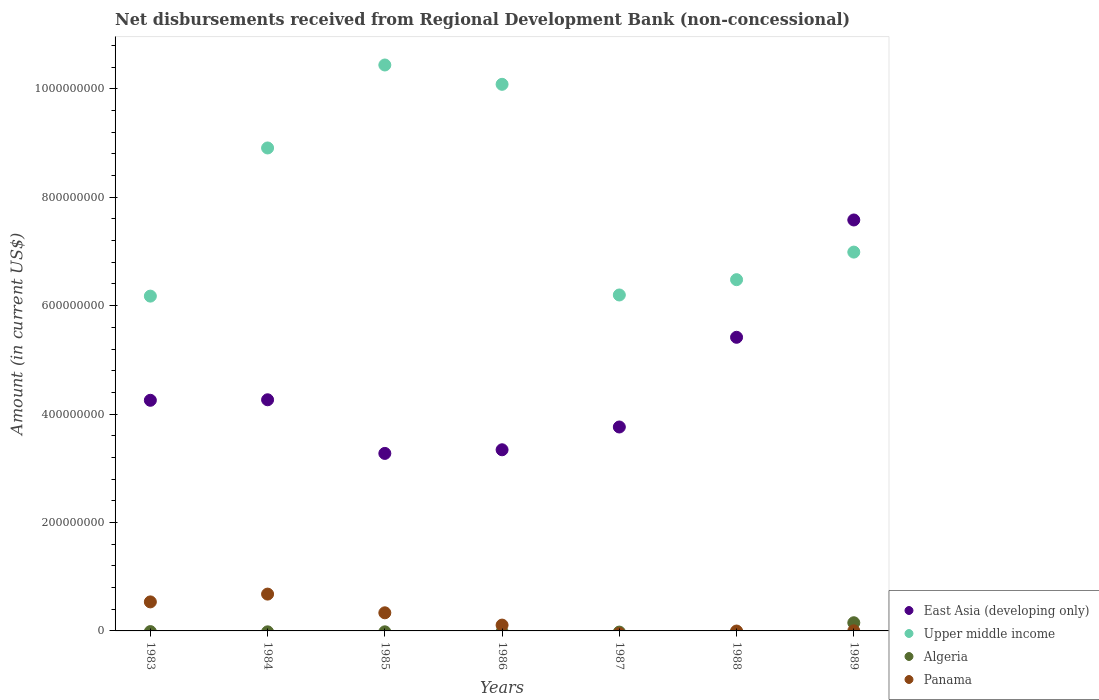How many different coloured dotlines are there?
Your answer should be very brief. 4. Is the number of dotlines equal to the number of legend labels?
Your response must be concise. No. What is the amount of disbursements received from Regional Development Bank in East Asia (developing only) in 1988?
Make the answer very short. 5.42e+08. Across all years, what is the maximum amount of disbursements received from Regional Development Bank in East Asia (developing only)?
Provide a succinct answer. 7.58e+08. Across all years, what is the minimum amount of disbursements received from Regional Development Bank in Algeria?
Give a very brief answer. 0. What is the total amount of disbursements received from Regional Development Bank in East Asia (developing only) in the graph?
Ensure brevity in your answer.  3.19e+09. What is the difference between the amount of disbursements received from Regional Development Bank in Panama in 1983 and that in 1986?
Provide a succinct answer. 4.28e+07. What is the difference between the amount of disbursements received from Regional Development Bank in Upper middle income in 1988 and the amount of disbursements received from Regional Development Bank in Algeria in 1989?
Provide a succinct answer. 6.33e+08. What is the average amount of disbursements received from Regional Development Bank in East Asia (developing only) per year?
Your response must be concise. 4.56e+08. In the year 1989, what is the difference between the amount of disbursements received from Regional Development Bank in Panama and amount of disbursements received from Regional Development Bank in Algeria?
Your answer should be compact. -1.49e+07. In how many years, is the amount of disbursements received from Regional Development Bank in Panama greater than 1000000000 US$?
Offer a terse response. 0. What is the ratio of the amount of disbursements received from Regional Development Bank in East Asia (developing only) in 1983 to that in 1988?
Provide a succinct answer. 0.79. Is the amount of disbursements received from Regional Development Bank in Upper middle income in 1983 less than that in 1988?
Your answer should be compact. Yes. What is the difference between the highest and the second highest amount of disbursements received from Regional Development Bank in East Asia (developing only)?
Offer a very short reply. 2.16e+08. What is the difference between the highest and the lowest amount of disbursements received from Regional Development Bank in East Asia (developing only)?
Make the answer very short. 4.31e+08. Is the sum of the amount of disbursements received from Regional Development Bank in Upper middle income in 1983 and 1989 greater than the maximum amount of disbursements received from Regional Development Bank in Algeria across all years?
Keep it short and to the point. Yes. Is it the case that in every year, the sum of the amount of disbursements received from Regional Development Bank in Panama and amount of disbursements received from Regional Development Bank in East Asia (developing only)  is greater than the sum of amount of disbursements received from Regional Development Bank in Upper middle income and amount of disbursements received from Regional Development Bank in Algeria?
Give a very brief answer. Yes. Is it the case that in every year, the sum of the amount of disbursements received from Regional Development Bank in Upper middle income and amount of disbursements received from Regional Development Bank in Panama  is greater than the amount of disbursements received from Regional Development Bank in Algeria?
Your response must be concise. Yes. Does the amount of disbursements received from Regional Development Bank in Algeria monotonically increase over the years?
Your response must be concise. No. Is the amount of disbursements received from Regional Development Bank in Algeria strictly less than the amount of disbursements received from Regional Development Bank in Upper middle income over the years?
Give a very brief answer. Yes. How many dotlines are there?
Offer a very short reply. 4. How many years are there in the graph?
Offer a very short reply. 7. Are the values on the major ticks of Y-axis written in scientific E-notation?
Keep it short and to the point. No. Where does the legend appear in the graph?
Offer a terse response. Bottom right. How many legend labels are there?
Give a very brief answer. 4. What is the title of the graph?
Keep it short and to the point. Net disbursements received from Regional Development Bank (non-concessional). Does "South Africa" appear as one of the legend labels in the graph?
Keep it short and to the point. No. What is the label or title of the Y-axis?
Ensure brevity in your answer.  Amount (in current US$). What is the Amount (in current US$) of East Asia (developing only) in 1983?
Your answer should be compact. 4.25e+08. What is the Amount (in current US$) of Upper middle income in 1983?
Your response must be concise. 6.18e+08. What is the Amount (in current US$) in Algeria in 1983?
Offer a very short reply. 0. What is the Amount (in current US$) in Panama in 1983?
Provide a short and direct response. 5.35e+07. What is the Amount (in current US$) of East Asia (developing only) in 1984?
Your response must be concise. 4.26e+08. What is the Amount (in current US$) of Upper middle income in 1984?
Your answer should be compact. 8.91e+08. What is the Amount (in current US$) in Panama in 1984?
Your response must be concise. 6.79e+07. What is the Amount (in current US$) of East Asia (developing only) in 1985?
Offer a terse response. 3.27e+08. What is the Amount (in current US$) of Upper middle income in 1985?
Offer a terse response. 1.04e+09. What is the Amount (in current US$) of Panama in 1985?
Offer a very short reply. 3.34e+07. What is the Amount (in current US$) in East Asia (developing only) in 1986?
Give a very brief answer. 3.34e+08. What is the Amount (in current US$) of Upper middle income in 1986?
Keep it short and to the point. 1.01e+09. What is the Amount (in current US$) of Algeria in 1986?
Your answer should be compact. 0. What is the Amount (in current US$) in Panama in 1986?
Offer a very short reply. 1.07e+07. What is the Amount (in current US$) of East Asia (developing only) in 1987?
Make the answer very short. 3.76e+08. What is the Amount (in current US$) in Upper middle income in 1987?
Your answer should be compact. 6.20e+08. What is the Amount (in current US$) of Algeria in 1987?
Your response must be concise. 0. What is the Amount (in current US$) in East Asia (developing only) in 1988?
Your answer should be very brief. 5.42e+08. What is the Amount (in current US$) of Upper middle income in 1988?
Provide a short and direct response. 6.48e+08. What is the Amount (in current US$) in Panama in 1988?
Offer a very short reply. 0. What is the Amount (in current US$) in East Asia (developing only) in 1989?
Your response must be concise. 7.58e+08. What is the Amount (in current US$) of Upper middle income in 1989?
Provide a short and direct response. 6.99e+08. What is the Amount (in current US$) in Algeria in 1989?
Keep it short and to the point. 1.51e+07. What is the Amount (in current US$) of Panama in 1989?
Your answer should be compact. 2.08e+05. Across all years, what is the maximum Amount (in current US$) in East Asia (developing only)?
Make the answer very short. 7.58e+08. Across all years, what is the maximum Amount (in current US$) of Upper middle income?
Provide a succinct answer. 1.04e+09. Across all years, what is the maximum Amount (in current US$) of Algeria?
Ensure brevity in your answer.  1.51e+07. Across all years, what is the maximum Amount (in current US$) of Panama?
Provide a succinct answer. 6.79e+07. Across all years, what is the minimum Amount (in current US$) in East Asia (developing only)?
Give a very brief answer. 3.27e+08. Across all years, what is the minimum Amount (in current US$) in Upper middle income?
Offer a terse response. 6.18e+08. Across all years, what is the minimum Amount (in current US$) in Panama?
Provide a succinct answer. 0. What is the total Amount (in current US$) of East Asia (developing only) in the graph?
Your answer should be very brief. 3.19e+09. What is the total Amount (in current US$) of Upper middle income in the graph?
Offer a very short reply. 5.53e+09. What is the total Amount (in current US$) in Algeria in the graph?
Offer a very short reply. 1.51e+07. What is the total Amount (in current US$) of Panama in the graph?
Offer a very short reply. 1.66e+08. What is the difference between the Amount (in current US$) of East Asia (developing only) in 1983 and that in 1984?
Provide a short and direct response. -9.45e+05. What is the difference between the Amount (in current US$) of Upper middle income in 1983 and that in 1984?
Make the answer very short. -2.73e+08. What is the difference between the Amount (in current US$) in Panama in 1983 and that in 1984?
Ensure brevity in your answer.  -1.44e+07. What is the difference between the Amount (in current US$) in East Asia (developing only) in 1983 and that in 1985?
Give a very brief answer. 9.80e+07. What is the difference between the Amount (in current US$) of Upper middle income in 1983 and that in 1985?
Your response must be concise. -4.26e+08. What is the difference between the Amount (in current US$) of Panama in 1983 and that in 1985?
Offer a very short reply. 2.01e+07. What is the difference between the Amount (in current US$) of East Asia (developing only) in 1983 and that in 1986?
Give a very brief answer. 9.13e+07. What is the difference between the Amount (in current US$) of Upper middle income in 1983 and that in 1986?
Provide a short and direct response. -3.91e+08. What is the difference between the Amount (in current US$) in Panama in 1983 and that in 1986?
Your answer should be compact. 4.28e+07. What is the difference between the Amount (in current US$) of East Asia (developing only) in 1983 and that in 1987?
Ensure brevity in your answer.  4.93e+07. What is the difference between the Amount (in current US$) in Upper middle income in 1983 and that in 1987?
Your answer should be compact. -2.11e+06. What is the difference between the Amount (in current US$) of East Asia (developing only) in 1983 and that in 1988?
Your response must be concise. -1.16e+08. What is the difference between the Amount (in current US$) of Upper middle income in 1983 and that in 1988?
Keep it short and to the point. -3.03e+07. What is the difference between the Amount (in current US$) in East Asia (developing only) in 1983 and that in 1989?
Provide a short and direct response. -3.33e+08. What is the difference between the Amount (in current US$) in Upper middle income in 1983 and that in 1989?
Your answer should be compact. -8.12e+07. What is the difference between the Amount (in current US$) of Panama in 1983 and that in 1989?
Provide a succinct answer. 5.33e+07. What is the difference between the Amount (in current US$) in East Asia (developing only) in 1984 and that in 1985?
Provide a short and direct response. 9.89e+07. What is the difference between the Amount (in current US$) of Upper middle income in 1984 and that in 1985?
Give a very brief answer. -1.53e+08. What is the difference between the Amount (in current US$) in Panama in 1984 and that in 1985?
Your response must be concise. 3.45e+07. What is the difference between the Amount (in current US$) in East Asia (developing only) in 1984 and that in 1986?
Your response must be concise. 9.22e+07. What is the difference between the Amount (in current US$) of Upper middle income in 1984 and that in 1986?
Your answer should be very brief. -1.17e+08. What is the difference between the Amount (in current US$) in Panama in 1984 and that in 1986?
Your response must be concise. 5.72e+07. What is the difference between the Amount (in current US$) of East Asia (developing only) in 1984 and that in 1987?
Offer a very short reply. 5.02e+07. What is the difference between the Amount (in current US$) in Upper middle income in 1984 and that in 1987?
Your response must be concise. 2.71e+08. What is the difference between the Amount (in current US$) of East Asia (developing only) in 1984 and that in 1988?
Ensure brevity in your answer.  -1.15e+08. What is the difference between the Amount (in current US$) in Upper middle income in 1984 and that in 1988?
Provide a short and direct response. 2.43e+08. What is the difference between the Amount (in current US$) of East Asia (developing only) in 1984 and that in 1989?
Your answer should be compact. -3.32e+08. What is the difference between the Amount (in current US$) of Upper middle income in 1984 and that in 1989?
Provide a short and direct response. 1.92e+08. What is the difference between the Amount (in current US$) of Panama in 1984 and that in 1989?
Ensure brevity in your answer.  6.77e+07. What is the difference between the Amount (in current US$) in East Asia (developing only) in 1985 and that in 1986?
Offer a terse response. -6.71e+06. What is the difference between the Amount (in current US$) in Upper middle income in 1985 and that in 1986?
Give a very brief answer. 3.57e+07. What is the difference between the Amount (in current US$) of Panama in 1985 and that in 1986?
Give a very brief answer. 2.27e+07. What is the difference between the Amount (in current US$) in East Asia (developing only) in 1985 and that in 1987?
Ensure brevity in your answer.  -4.87e+07. What is the difference between the Amount (in current US$) in Upper middle income in 1985 and that in 1987?
Ensure brevity in your answer.  4.24e+08. What is the difference between the Amount (in current US$) in East Asia (developing only) in 1985 and that in 1988?
Offer a terse response. -2.14e+08. What is the difference between the Amount (in current US$) in Upper middle income in 1985 and that in 1988?
Ensure brevity in your answer.  3.96e+08. What is the difference between the Amount (in current US$) of East Asia (developing only) in 1985 and that in 1989?
Your response must be concise. -4.31e+08. What is the difference between the Amount (in current US$) of Upper middle income in 1985 and that in 1989?
Offer a very short reply. 3.45e+08. What is the difference between the Amount (in current US$) of Panama in 1985 and that in 1989?
Your response must be concise. 3.32e+07. What is the difference between the Amount (in current US$) of East Asia (developing only) in 1986 and that in 1987?
Your answer should be compact. -4.20e+07. What is the difference between the Amount (in current US$) of Upper middle income in 1986 and that in 1987?
Offer a very short reply. 3.89e+08. What is the difference between the Amount (in current US$) of East Asia (developing only) in 1986 and that in 1988?
Offer a terse response. -2.07e+08. What is the difference between the Amount (in current US$) in Upper middle income in 1986 and that in 1988?
Provide a short and direct response. 3.60e+08. What is the difference between the Amount (in current US$) of East Asia (developing only) in 1986 and that in 1989?
Ensure brevity in your answer.  -4.24e+08. What is the difference between the Amount (in current US$) of Upper middle income in 1986 and that in 1989?
Offer a very short reply. 3.09e+08. What is the difference between the Amount (in current US$) in Panama in 1986 and that in 1989?
Provide a short and direct response. 1.05e+07. What is the difference between the Amount (in current US$) in East Asia (developing only) in 1987 and that in 1988?
Your answer should be compact. -1.65e+08. What is the difference between the Amount (in current US$) of Upper middle income in 1987 and that in 1988?
Your response must be concise. -2.82e+07. What is the difference between the Amount (in current US$) of East Asia (developing only) in 1987 and that in 1989?
Give a very brief answer. -3.82e+08. What is the difference between the Amount (in current US$) in Upper middle income in 1987 and that in 1989?
Your answer should be very brief. -7.91e+07. What is the difference between the Amount (in current US$) of East Asia (developing only) in 1988 and that in 1989?
Keep it short and to the point. -2.16e+08. What is the difference between the Amount (in current US$) in Upper middle income in 1988 and that in 1989?
Keep it short and to the point. -5.09e+07. What is the difference between the Amount (in current US$) of East Asia (developing only) in 1983 and the Amount (in current US$) of Upper middle income in 1984?
Give a very brief answer. -4.65e+08. What is the difference between the Amount (in current US$) of East Asia (developing only) in 1983 and the Amount (in current US$) of Panama in 1984?
Ensure brevity in your answer.  3.57e+08. What is the difference between the Amount (in current US$) in Upper middle income in 1983 and the Amount (in current US$) in Panama in 1984?
Provide a short and direct response. 5.50e+08. What is the difference between the Amount (in current US$) of East Asia (developing only) in 1983 and the Amount (in current US$) of Upper middle income in 1985?
Provide a short and direct response. -6.18e+08. What is the difference between the Amount (in current US$) in East Asia (developing only) in 1983 and the Amount (in current US$) in Panama in 1985?
Keep it short and to the point. 3.92e+08. What is the difference between the Amount (in current US$) in Upper middle income in 1983 and the Amount (in current US$) in Panama in 1985?
Provide a succinct answer. 5.84e+08. What is the difference between the Amount (in current US$) in East Asia (developing only) in 1983 and the Amount (in current US$) in Upper middle income in 1986?
Keep it short and to the point. -5.83e+08. What is the difference between the Amount (in current US$) of East Asia (developing only) in 1983 and the Amount (in current US$) of Panama in 1986?
Ensure brevity in your answer.  4.15e+08. What is the difference between the Amount (in current US$) of Upper middle income in 1983 and the Amount (in current US$) of Panama in 1986?
Your response must be concise. 6.07e+08. What is the difference between the Amount (in current US$) of East Asia (developing only) in 1983 and the Amount (in current US$) of Upper middle income in 1987?
Your answer should be compact. -1.94e+08. What is the difference between the Amount (in current US$) in East Asia (developing only) in 1983 and the Amount (in current US$) in Upper middle income in 1988?
Provide a short and direct response. -2.22e+08. What is the difference between the Amount (in current US$) of East Asia (developing only) in 1983 and the Amount (in current US$) of Upper middle income in 1989?
Ensure brevity in your answer.  -2.73e+08. What is the difference between the Amount (in current US$) of East Asia (developing only) in 1983 and the Amount (in current US$) of Algeria in 1989?
Offer a terse response. 4.10e+08. What is the difference between the Amount (in current US$) of East Asia (developing only) in 1983 and the Amount (in current US$) of Panama in 1989?
Offer a terse response. 4.25e+08. What is the difference between the Amount (in current US$) of Upper middle income in 1983 and the Amount (in current US$) of Algeria in 1989?
Your answer should be compact. 6.02e+08. What is the difference between the Amount (in current US$) in Upper middle income in 1983 and the Amount (in current US$) in Panama in 1989?
Offer a terse response. 6.17e+08. What is the difference between the Amount (in current US$) in East Asia (developing only) in 1984 and the Amount (in current US$) in Upper middle income in 1985?
Ensure brevity in your answer.  -6.18e+08. What is the difference between the Amount (in current US$) of East Asia (developing only) in 1984 and the Amount (in current US$) of Panama in 1985?
Keep it short and to the point. 3.93e+08. What is the difference between the Amount (in current US$) of Upper middle income in 1984 and the Amount (in current US$) of Panama in 1985?
Make the answer very short. 8.57e+08. What is the difference between the Amount (in current US$) of East Asia (developing only) in 1984 and the Amount (in current US$) of Upper middle income in 1986?
Your response must be concise. -5.82e+08. What is the difference between the Amount (in current US$) in East Asia (developing only) in 1984 and the Amount (in current US$) in Panama in 1986?
Ensure brevity in your answer.  4.16e+08. What is the difference between the Amount (in current US$) of Upper middle income in 1984 and the Amount (in current US$) of Panama in 1986?
Your response must be concise. 8.80e+08. What is the difference between the Amount (in current US$) in East Asia (developing only) in 1984 and the Amount (in current US$) in Upper middle income in 1987?
Provide a short and direct response. -1.93e+08. What is the difference between the Amount (in current US$) of East Asia (developing only) in 1984 and the Amount (in current US$) of Upper middle income in 1988?
Offer a terse response. -2.22e+08. What is the difference between the Amount (in current US$) in East Asia (developing only) in 1984 and the Amount (in current US$) in Upper middle income in 1989?
Make the answer very short. -2.72e+08. What is the difference between the Amount (in current US$) of East Asia (developing only) in 1984 and the Amount (in current US$) of Algeria in 1989?
Offer a terse response. 4.11e+08. What is the difference between the Amount (in current US$) of East Asia (developing only) in 1984 and the Amount (in current US$) of Panama in 1989?
Your answer should be very brief. 4.26e+08. What is the difference between the Amount (in current US$) of Upper middle income in 1984 and the Amount (in current US$) of Algeria in 1989?
Your answer should be very brief. 8.76e+08. What is the difference between the Amount (in current US$) in Upper middle income in 1984 and the Amount (in current US$) in Panama in 1989?
Make the answer very short. 8.91e+08. What is the difference between the Amount (in current US$) in East Asia (developing only) in 1985 and the Amount (in current US$) in Upper middle income in 1986?
Give a very brief answer. -6.81e+08. What is the difference between the Amount (in current US$) in East Asia (developing only) in 1985 and the Amount (in current US$) in Panama in 1986?
Your answer should be compact. 3.17e+08. What is the difference between the Amount (in current US$) in Upper middle income in 1985 and the Amount (in current US$) in Panama in 1986?
Give a very brief answer. 1.03e+09. What is the difference between the Amount (in current US$) of East Asia (developing only) in 1985 and the Amount (in current US$) of Upper middle income in 1987?
Ensure brevity in your answer.  -2.92e+08. What is the difference between the Amount (in current US$) of East Asia (developing only) in 1985 and the Amount (in current US$) of Upper middle income in 1988?
Keep it short and to the point. -3.20e+08. What is the difference between the Amount (in current US$) of East Asia (developing only) in 1985 and the Amount (in current US$) of Upper middle income in 1989?
Ensure brevity in your answer.  -3.71e+08. What is the difference between the Amount (in current US$) of East Asia (developing only) in 1985 and the Amount (in current US$) of Algeria in 1989?
Your response must be concise. 3.12e+08. What is the difference between the Amount (in current US$) in East Asia (developing only) in 1985 and the Amount (in current US$) in Panama in 1989?
Keep it short and to the point. 3.27e+08. What is the difference between the Amount (in current US$) of Upper middle income in 1985 and the Amount (in current US$) of Algeria in 1989?
Keep it short and to the point. 1.03e+09. What is the difference between the Amount (in current US$) in Upper middle income in 1985 and the Amount (in current US$) in Panama in 1989?
Your answer should be compact. 1.04e+09. What is the difference between the Amount (in current US$) of East Asia (developing only) in 1986 and the Amount (in current US$) of Upper middle income in 1987?
Your response must be concise. -2.86e+08. What is the difference between the Amount (in current US$) in East Asia (developing only) in 1986 and the Amount (in current US$) in Upper middle income in 1988?
Ensure brevity in your answer.  -3.14e+08. What is the difference between the Amount (in current US$) in East Asia (developing only) in 1986 and the Amount (in current US$) in Upper middle income in 1989?
Make the answer very short. -3.65e+08. What is the difference between the Amount (in current US$) of East Asia (developing only) in 1986 and the Amount (in current US$) of Algeria in 1989?
Offer a terse response. 3.19e+08. What is the difference between the Amount (in current US$) in East Asia (developing only) in 1986 and the Amount (in current US$) in Panama in 1989?
Provide a short and direct response. 3.34e+08. What is the difference between the Amount (in current US$) of Upper middle income in 1986 and the Amount (in current US$) of Algeria in 1989?
Keep it short and to the point. 9.93e+08. What is the difference between the Amount (in current US$) of Upper middle income in 1986 and the Amount (in current US$) of Panama in 1989?
Offer a terse response. 1.01e+09. What is the difference between the Amount (in current US$) of East Asia (developing only) in 1987 and the Amount (in current US$) of Upper middle income in 1988?
Ensure brevity in your answer.  -2.72e+08. What is the difference between the Amount (in current US$) of East Asia (developing only) in 1987 and the Amount (in current US$) of Upper middle income in 1989?
Provide a succinct answer. -3.23e+08. What is the difference between the Amount (in current US$) of East Asia (developing only) in 1987 and the Amount (in current US$) of Algeria in 1989?
Your response must be concise. 3.61e+08. What is the difference between the Amount (in current US$) of East Asia (developing only) in 1987 and the Amount (in current US$) of Panama in 1989?
Your answer should be compact. 3.76e+08. What is the difference between the Amount (in current US$) in Upper middle income in 1987 and the Amount (in current US$) in Algeria in 1989?
Make the answer very short. 6.05e+08. What is the difference between the Amount (in current US$) of Upper middle income in 1987 and the Amount (in current US$) of Panama in 1989?
Your answer should be very brief. 6.19e+08. What is the difference between the Amount (in current US$) of East Asia (developing only) in 1988 and the Amount (in current US$) of Upper middle income in 1989?
Keep it short and to the point. -1.57e+08. What is the difference between the Amount (in current US$) in East Asia (developing only) in 1988 and the Amount (in current US$) in Algeria in 1989?
Provide a short and direct response. 5.27e+08. What is the difference between the Amount (in current US$) in East Asia (developing only) in 1988 and the Amount (in current US$) in Panama in 1989?
Provide a short and direct response. 5.41e+08. What is the difference between the Amount (in current US$) of Upper middle income in 1988 and the Amount (in current US$) of Algeria in 1989?
Give a very brief answer. 6.33e+08. What is the difference between the Amount (in current US$) of Upper middle income in 1988 and the Amount (in current US$) of Panama in 1989?
Your answer should be compact. 6.48e+08. What is the average Amount (in current US$) of East Asia (developing only) per year?
Your answer should be compact. 4.56e+08. What is the average Amount (in current US$) of Upper middle income per year?
Provide a succinct answer. 7.90e+08. What is the average Amount (in current US$) in Algeria per year?
Your response must be concise. 2.16e+06. What is the average Amount (in current US$) of Panama per year?
Provide a short and direct response. 2.37e+07. In the year 1983, what is the difference between the Amount (in current US$) of East Asia (developing only) and Amount (in current US$) of Upper middle income?
Your answer should be compact. -1.92e+08. In the year 1983, what is the difference between the Amount (in current US$) of East Asia (developing only) and Amount (in current US$) of Panama?
Ensure brevity in your answer.  3.72e+08. In the year 1983, what is the difference between the Amount (in current US$) of Upper middle income and Amount (in current US$) of Panama?
Offer a very short reply. 5.64e+08. In the year 1984, what is the difference between the Amount (in current US$) in East Asia (developing only) and Amount (in current US$) in Upper middle income?
Keep it short and to the point. -4.64e+08. In the year 1984, what is the difference between the Amount (in current US$) of East Asia (developing only) and Amount (in current US$) of Panama?
Keep it short and to the point. 3.58e+08. In the year 1984, what is the difference between the Amount (in current US$) of Upper middle income and Amount (in current US$) of Panama?
Give a very brief answer. 8.23e+08. In the year 1985, what is the difference between the Amount (in current US$) of East Asia (developing only) and Amount (in current US$) of Upper middle income?
Offer a terse response. -7.16e+08. In the year 1985, what is the difference between the Amount (in current US$) in East Asia (developing only) and Amount (in current US$) in Panama?
Your response must be concise. 2.94e+08. In the year 1985, what is the difference between the Amount (in current US$) in Upper middle income and Amount (in current US$) in Panama?
Offer a terse response. 1.01e+09. In the year 1986, what is the difference between the Amount (in current US$) in East Asia (developing only) and Amount (in current US$) in Upper middle income?
Provide a succinct answer. -6.74e+08. In the year 1986, what is the difference between the Amount (in current US$) of East Asia (developing only) and Amount (in current US$) of Panama?
Your response must be concise. 3.23e+08. In the year 1986, what is the difference between the Amount (in current US$) in Upper middle income and Amount (in current US$) in Panama?
Make the answer very short. 9.97e+08. In the year 1987, what is the difference between the Amount (in current US$) in East Asia (developing only) and Amount (in current US$) in Upper middle income?
Provide a short and direct response. -2.44e+08. In the year 1988, what is the difference between the Amount (in current US$) in East Asia (developing only) and Amount (in current US$) in Upper middle income?
Offer a very short reply. -1.06e+08. In the year 1989, what is the difference between the Amount (in current US$) of East Asia (developing only) and Amount (in current US$) of Upper middle income?
Ensure brevity in your answer.  5.93e+07. In the year 1989, what is the difference between the Amount (in current US$) in East Asia (developing only) and Amount (in current US$) in Algeria?
Make the answer very short. 7.43e+08. In the year 1989, what is the difference between the Amount (in current US$) of East Asia (developing only) and Amount (in current US$) of Panama?
Your answer should be very brief. 7.58e+08. In the year 1989, what is the difference between the Amount (in current US$) of Upper middle income and Amount (in current US$) of Algeria?
Keep it short and to the point. 6.84e+08. In the year 1989, what is the difference between the Amount (in current US$) of Upper middle income and Amount (in current US$) of Panama?
Your response must be concise. 6.99e+08. In the year 1989, what is the difference between the Amount (in current US$) in Algeria and Amount (in current US$) in Panama?
Offer a very short reply. 1.49e+07. What is the ratio of the Amount (in current US$) of East Asia (developing only) in 1983 to that in 1984?
Make the answer very short. 1. What is the ratio of the Amount (in current US$) of Upper middle income in 1983 to that in 1984?
Give a very brief answer. 0.69. What is the ratio of the Amount (in current US$) in Panama in 1983 to that in 1984?
Ensure brevity in your answer.  0.79. What is the ratio of the Amount (in current US$) in East Asia (developing only) in 1983 to that in 1985?
Ensure brevity in your answer.  1.3. What is the ratio of the Amount (in current US$) in Upper middle income in 1983 to that in 1985?
Your response must be concise. 0.59. What is the ratio of the Amount (in current US$) in Panama in 1983 to that in 1985?
Give a very brief answer. 1.6. What is the ratio of the Amount (in current US$) in East Asia (developing only) in 1983 to that in 1986?
Ensure brevity in your answer.  1.27. What is the ratio of the Amount (in current US$) of Upper middle income in 1983 to that in 1986?
Your response must be concise. 0.61. What is the ratio of the Amount (in current US$) in Panama in 1983 to that in 1986?
Give a very brief answer. 4.99. What is the ratio of the Amount (in current US$) in East Asia (developing only) in 1983 to that in 1987?
Provide a short and direct response. 1.13. What is the ratio of the Amount (in current US$) of Upper middle income in 1983 to that in 1987?
Provide a short and direct response. 1. What is the ratio of the Amount (in current US$) of East Asia (developing only) in 1983 to that in 1988?
Make the answer very short. 0.79. What is the ratio of the Amount (in current US$) of Upper middle income in 1983 to that in 1988?
Make the answer very short. 0.95. What is the ratio of the Amount (in current US$) in East Asia (developing only) in 1983 to that in 1989?
Make the answer very short. 0.56. What is the ratio of the Amount (in current US$) of Upper middle income in 1983 to that in 1989?
Offer a terse response. 0.88. What is the ratio of the Amount (in current US$) in Panama in 1983 to that in 1989?
Your answer should be very brief. 257.39. What is the ratio of the Amount (in current US$) of East Asia (developing only) in 1984 to that in 1985?
Give a very brief answer. 1.3. What is the ratio of the Amount (in current US$) in Upper middle income in 1984 to that in 1985?
Provide a succinct answer. 0.85. What is the ratio of the Amount (in current US$) in Panama in 1984 to that in 1985?
Keep it short and to the point. 2.03. What is the ratio of the Amount (in current US$) of East Asia (developing only) in 1984 to that in 1986?
Give a very brief answer. 1.28. What is the ratio of the Amount (in current US$) of Upper middle income in 1984 to that in 1986?
Ensure brevity in your answer.  0.88. What is the ratio of the Amount (in current US$) in Panama in 1984 to that in 1986?
Offer a very short reply. 6.33. What is the ratio of the Amount (in current US$) of East Asia (developing only) in 1984 to that in 1987?
Offer a very short reply. 1.13. What is the ratio of the Amount (in current US$) in Upper middle income in 1984 to that in 1987?
Offer a terse response. 1.44. What is the ratio of the Amount (in current US$) in East Asia (developing only) in 1984 to that in 1988?
Your answer should be compact. 0.79. What is the ratio of the Amount (in current US$) of Upper middle income in 1984 to that in 1988?
Provide a succinct answer. 1.38. What is the ratio of the Amount (in current US$) in East Asia (developing only) in 1984 to that in 1989?
Offer a very short reply. 0.56. What is the ratio of the Amount (in current US$) of Upper middle income in 1984 to that in 1989?
Offer a terse response. 1.27. What is the ratio of the Amount (in current US$) of Panama in 1984 to that in 1989?
Make the answer very short. 326.52. What is the ratio of the Amount (in current US$) in East Asia (developing only) in 1985 to that in 1986?
Keep it short and to the point. 0.98. What is the ratio of the Amount (in current US$) in Upper middle income in 1985 to that in 1986?
Offer a terse response. 1.04. What is the ratio of the Amount (in current US$) in Panama in 1985 to that in 1986?
Keep it short and to the point. 3.11. What is the ratio of the Amount (in current US$) of East Asia (developing only) in 1985 to that in 1987?
Ensure brevity in your answer.  0.87. What is the ratio of the Amount (in current US$) of Upper middle income in 1985 to that in 1987?
Provide a short and direct response. 1.68. What is the ratio of the Amount (in current US$) of East Asia (developing only) in 1985 to that in 1988?
Your answer should be compact. 0.6. What is the ratio of the Amount (in current US$) of Upper middle income in 1985 to that in 1988?
Keep it short and to the point. 1.61. What is the ratio of the Amount (in current US$) of East Asia (developing only) in 1985 to that in 1989?
Your response must be concise. 0.43. What is the ratio of the Amount (in current US$) in Upper middle income in 1985 to that in 1989?
Give a very brief answer. 1.49. What is the ratio of the Amount (in current US$) in Panama in 1985 to that in 1989?
Keep it short and to the point. 160.66. What is the ratio of the Amount (in current US$) of East Asia (developing only) in 1986 to that in 1987?
Give a very brief answer. 0.89. What is the ratio of the Amount (in current US$) in Upper middle income in 1986 to that in 1987?
Your answer should be compact. 1.63. What is the ratio of the Amount (in current US$) of East Asia (developing only) in 1986 to that in 1988?
Offer a very short reply. 0.62. What is the ratio of the Amount (in current US$) in Upper middle income in 1986 to that in 1988?
Provide a short and direct response. 1.56. What is the ratio of the Amount (in current US$) of East Asia (developing only) in 1986 to that in 1989?
Keep it short and to the point. 0.44. What is the ratio of the Amount (in current US$) in Upper middle income in 1986 to that in 1989?
Provide a succinct answer. 1.44. What is the ratio of the Amount (in current US$) of Panama in 1986 to that in 1989?
Your answer should be very brief. 51.6. What is the ratio of the Amount (in current US$) of East Asia (developing only) in 1987 to that in 1988?
Your response must be concise. 0.69. What is the ratio of the Amount (in current US$) in Upper middle income in 1987 to that in 1988?
Your answer should be very brief. 0.96. What is the ratio of the Amount (in current US$) of East Asia (developing only) in 1987 to that in 1989?
Offer a very short reply. 0.5. What is the ratio of the Amount (in current US$) in Upper middle income in 1987 to that in 1989?
Provide a succinct answer. 0.89. What is the ratio of the Amount (in current US$) in East Asia (developing only) in 1988 to that in 1989?
Your response must be concise. 0.71. What is the ratio of the Amount (in current US$) in Upper middle income in 1988 to that in 1989?
Offer a terse response. 0.93. What is the difference between the highest and the second highest Amount (in current US$) in East Asia (developing only)?
Keep it short and to the point. 2.16e+08. What is the difference between the highest and the second highest Amount (in current US$) in Upper middle income?
Keep it short and to the point. 3.57e+07. What is the difference between the highest and the second highest Amount (in current US$) in Panama?
Keep it short and to the point. 1.44e+07. What is the difference between the highest and the lowest Amount (in current US$) of East Asia (developing only)?
Offer a terse response. 4.31e+08. What is the difference between the highest and the lowest Amount (in current US$) in Upper middle income?
Make the answer very short. 4.26e+08. What is the difference between the highest and the lowest Amount (in current US$) in Algeria?
Your answer should be very brief. 1.51e+07. What is the difference between the highest and the lowest Amount (in current US$) of Panama?
Provide a succinct answer. 6.79e+07. 